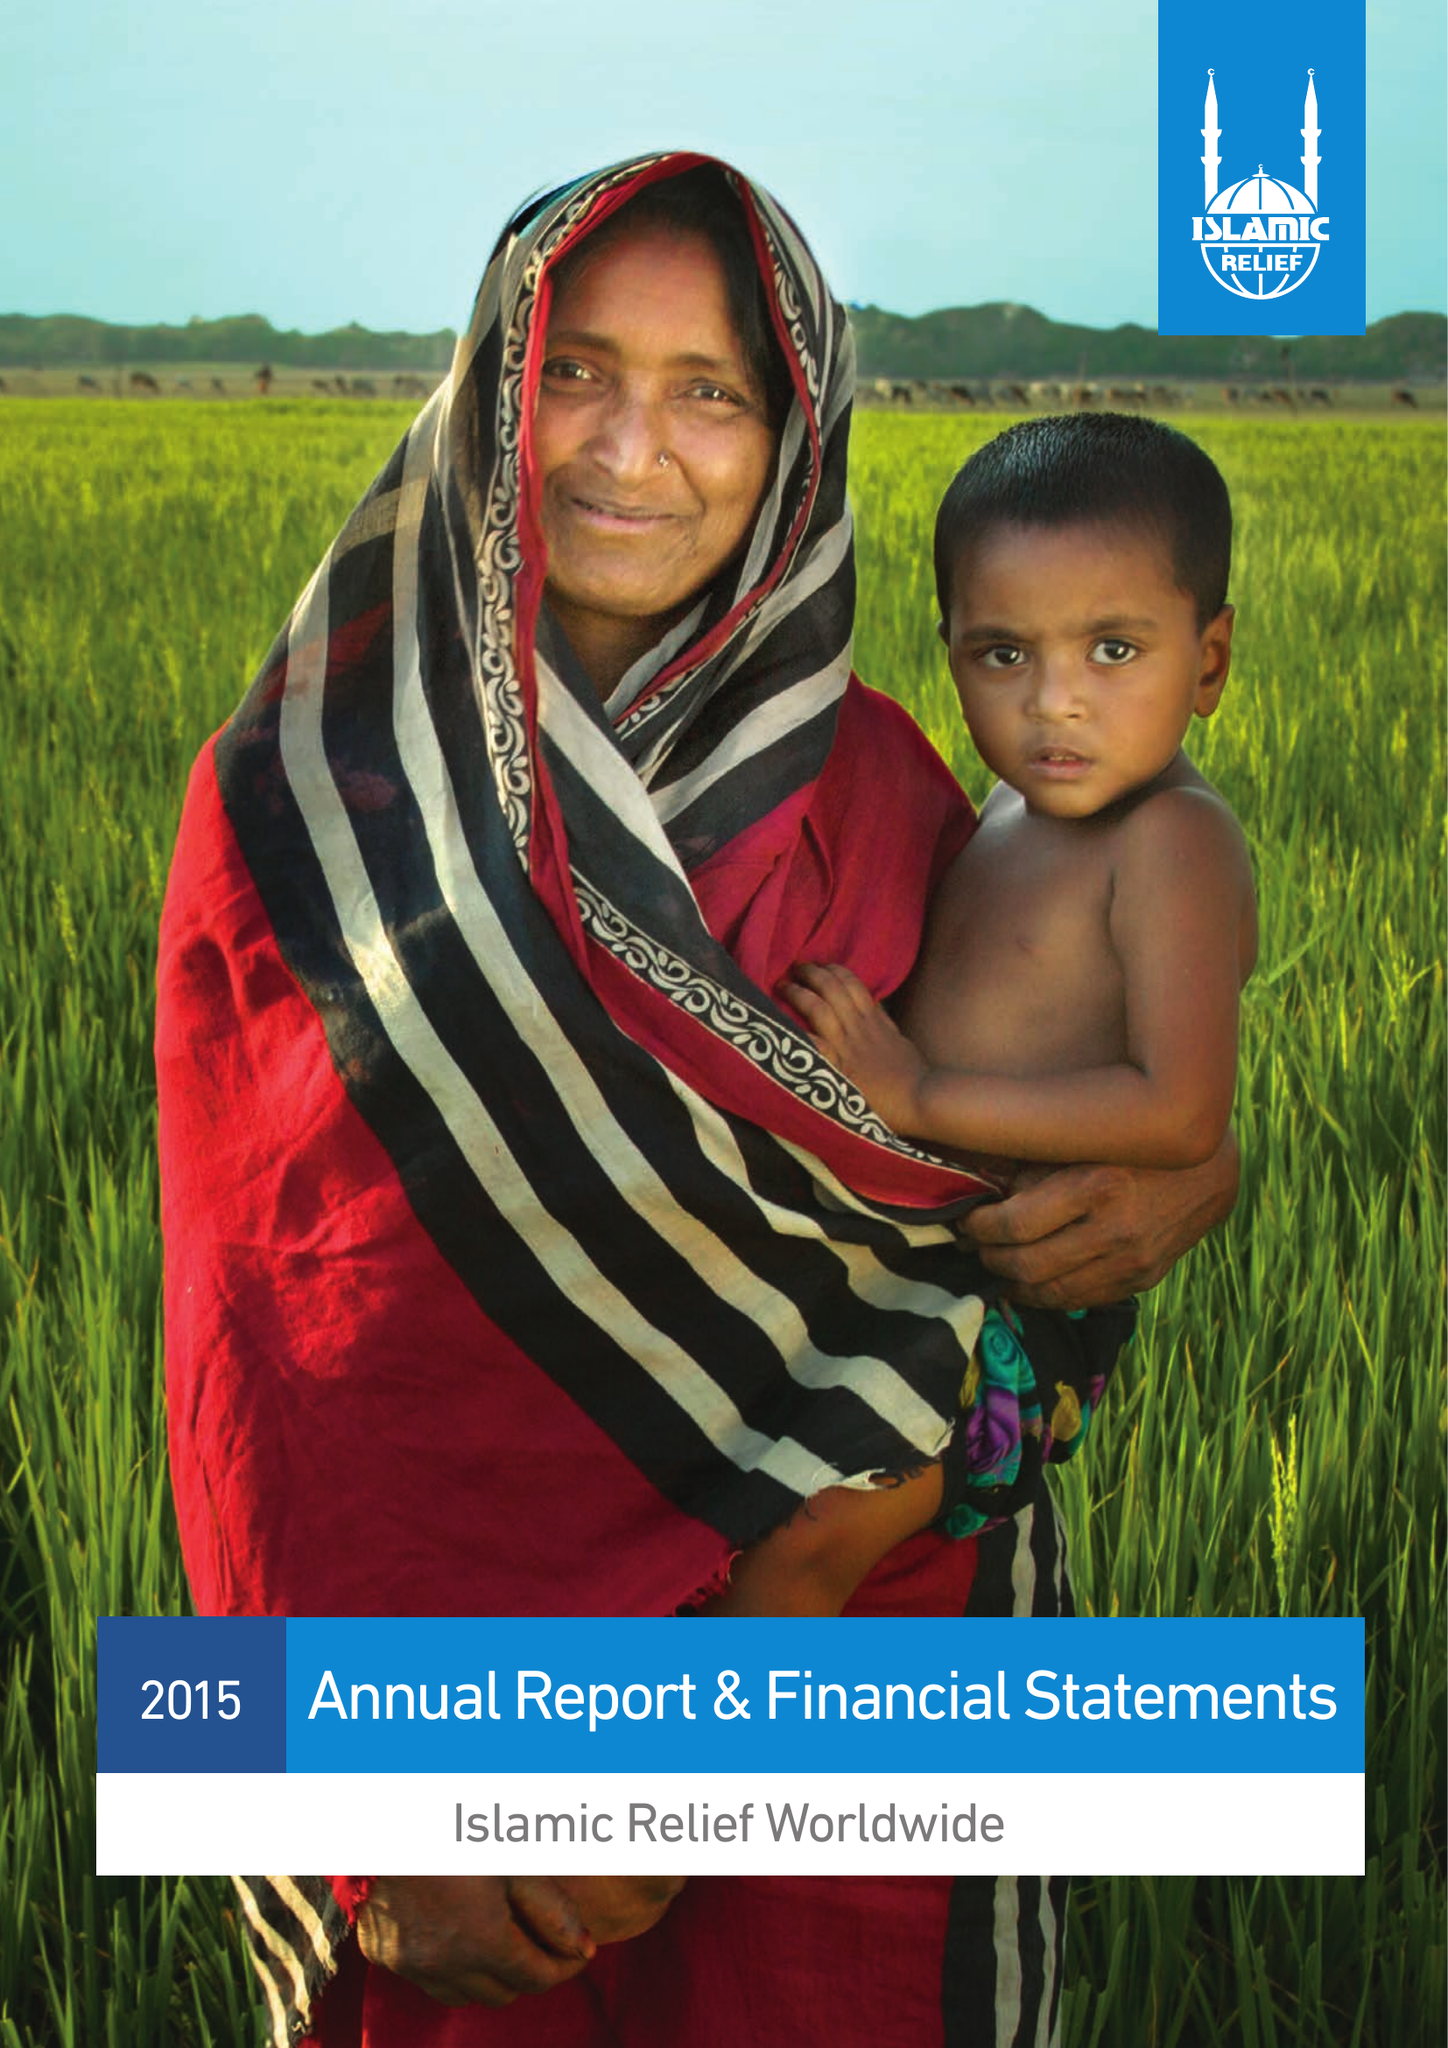What is the value for the charity_name?
Answer the question using a single word or phrase. Islamic Relief Worldwide 